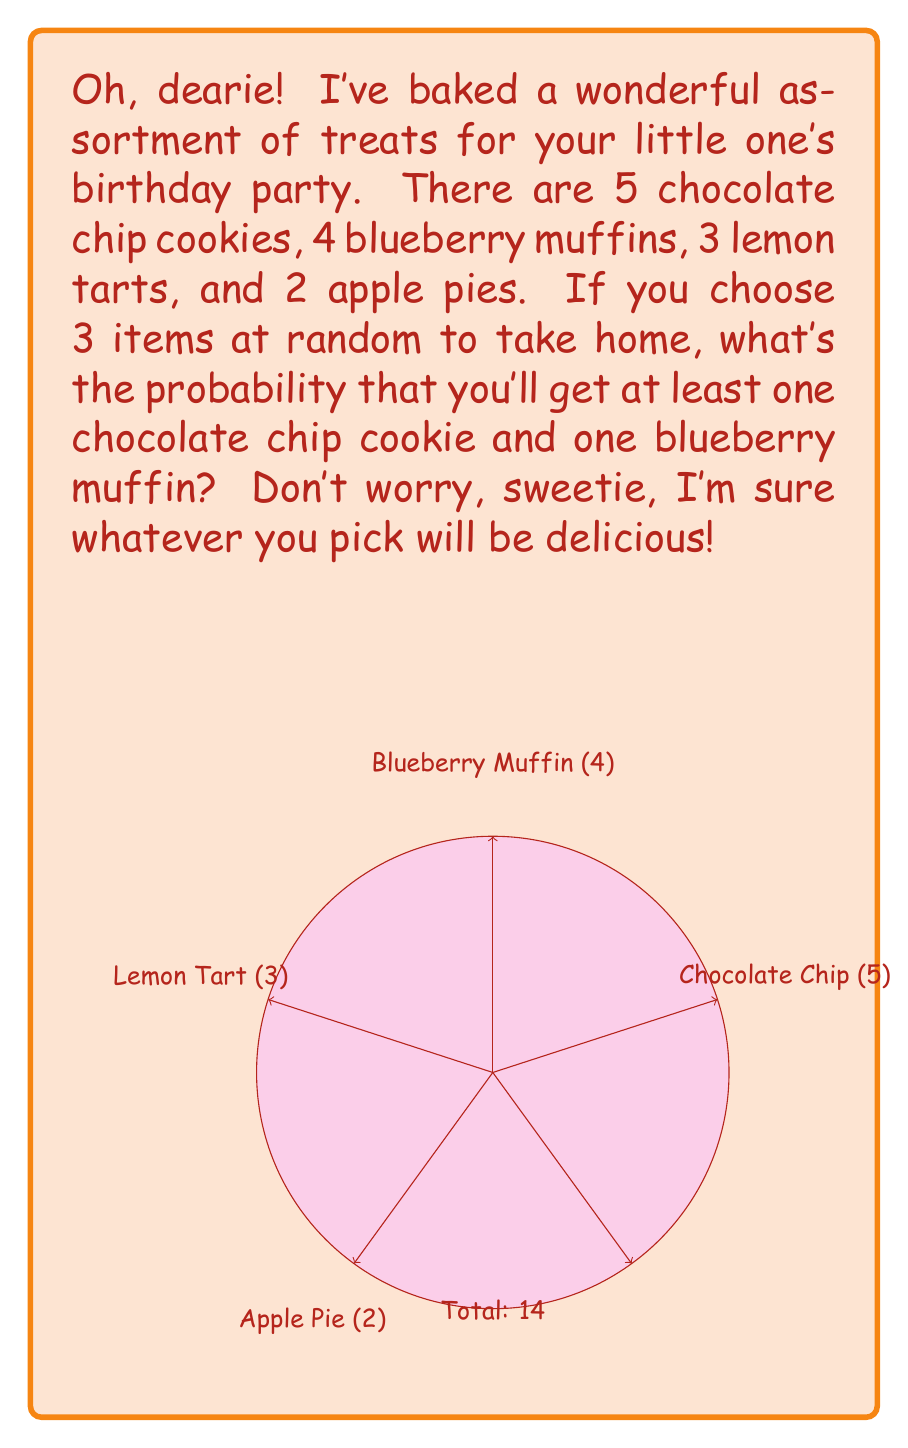Show me your answer to this math problem. Let's approach this step-by-step, dearie:

1) First, we need to calculate the total number of ways to choose 3 items from 14. This is given by the combination formula:

   $$\binom{14}{3} = \frac{14!}{3!(14-3)!} = \frac{14!}{3!11!} = 364$$

2) Now, we need to find the number of favorable outcomes. We can break this into two cases:
   a) 2 chocolate chip cookies and 1 blueberry muffin
   b) 1 chocolate chip cookie and 1 blueberry muffin, and 1 of any other item

3) For case a:
   $$\binom{5}{2} \cdot \binom{4}{1} = 10 \cdot 4 = 40$$

4) For case b:
   $$\binom{5}{1} \cdot \binom{4}{1} \cdot \binom{5}{1} = 5 \cdot 4 \cdot 5 = 100$$

5) Total favorable outcomes: 40 + 100 = 140

6) The probability is then:

   $$P(\text{at least one cookie and one muffin}) = \frac{\text{favorable outcomes}}{\text{total outcomes}} = \frac{140}{364}$$

7) This can be simplified to:

   $$\frac{140}{364} = \frac{35}{91} \approx 0.3846$$
Answer: $\frac{35}{91}$ 